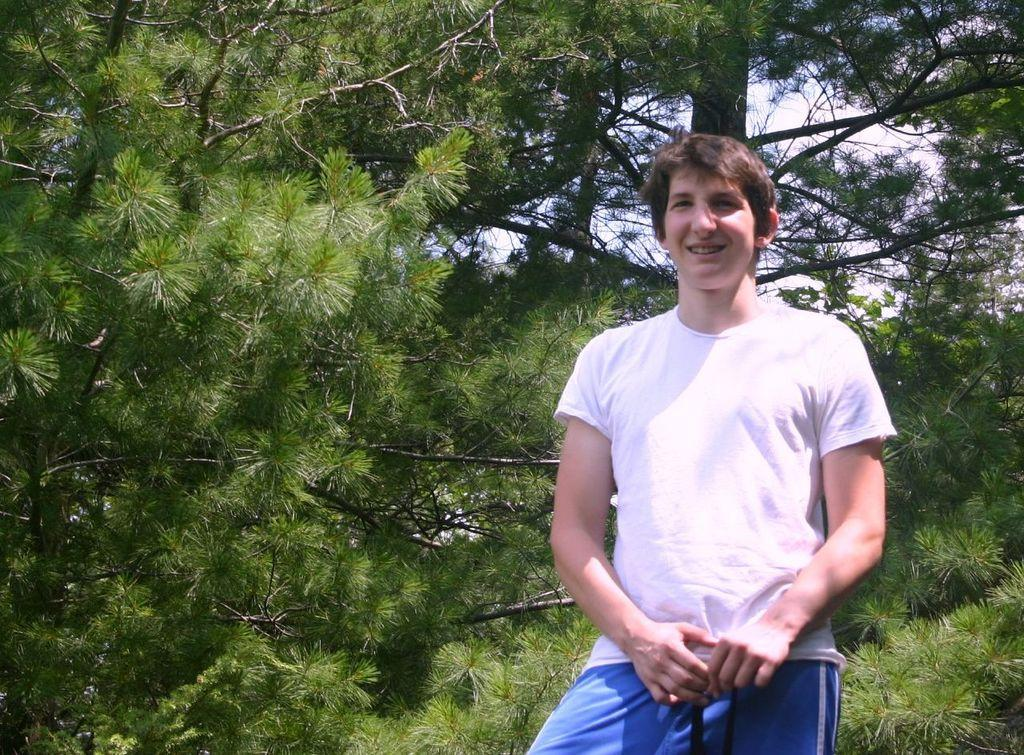Who is present in the image? There is a man in the image. What is the man's facial expression? The man has a smiling face. What is the man wearing? The man is wearing a white T-shirt. What is the man's posture in the image? The man is standing. What can be seen in the background of the image? There are trees and the sky visible in the background of the image. What type of leaf is the man holding in the image? There is no leaf present in the image; the man is not holding anything. 